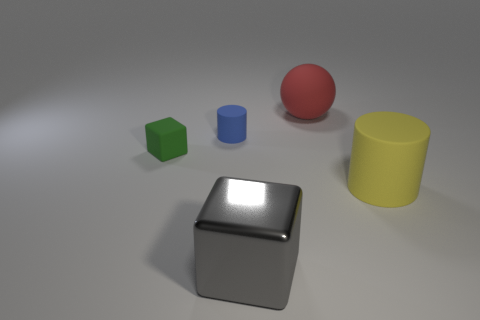The green cube is what size?
Your answer should be very brief. Small. What number of green rubber cylinders are the same size as the ball?
Ensure brevity in your answer.  0. Is the cylinder that is right of the red matte thing made of the same material as the cube that is in front of the small green thing?
Make the answer very short. No. What is the cylinder on the left side of the big matte object in front of the sphere made of?
Your response must be concise. Rubber. There is a object that is in front of the big yellow rubber object; what material is it?
Give a very brief answer. Metal. How many blue rubber things have the same shape as the large yellow object?
Make the answer very short. 1. Do the small block and the metal cube have the same color?
Provide a succinct answer. No. The cylinder that is left of the large rubber object that is in front of the large thing behind the yellow rubber object is made of what material?
Your response must be concise. Rubber. There is a blue matte object; are there any small blue objects right of it?
Make the answer very short. No. What is the shape of the other matte object that is the same size as the blue thing?
Your answer should be compact. Cube. 